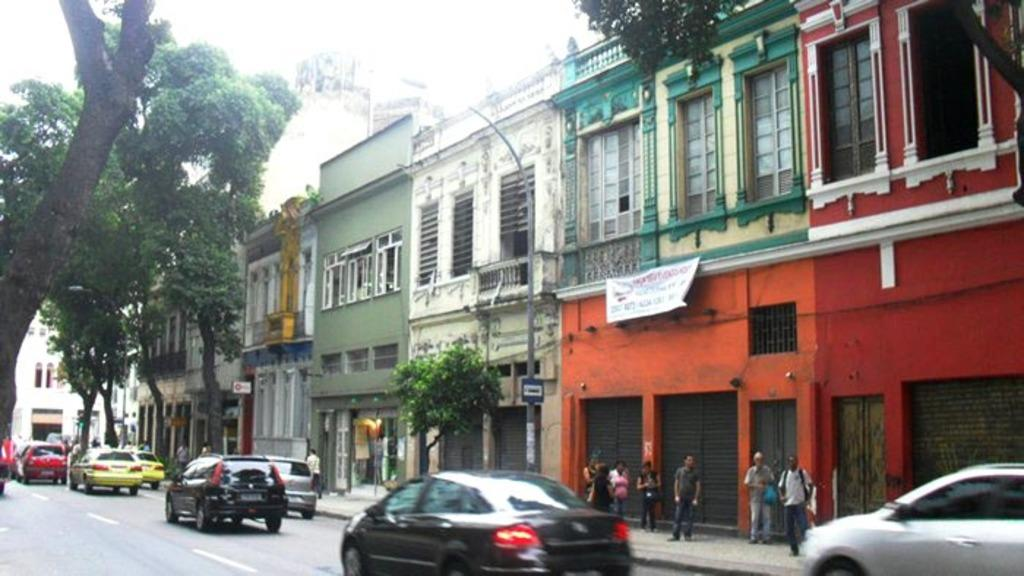What type of structures can be seen in the image? There are many buildings in the image. What else can be seen in the image besides buildings? There are many trees in the image. Are there any vehicles visible in the image? Yes, a few cars are moving on the road. What are the people in the image doing? A group of people are standing on the footpath. How many crows are sitting on the trees in the image? There are no crows visible in the image; it only features buildings, trees, cars, and people. 